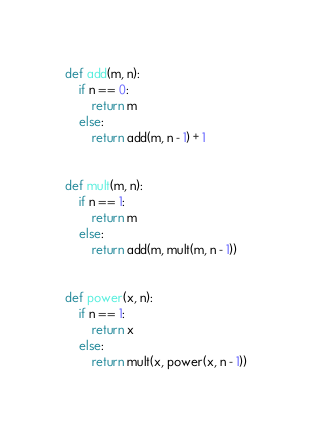Convert code to text. <code><loc_0><loc_0><loc_500><loc_500><_Python_>def add(m, n):
    if n == 0:
        return m
    else:
        return add(m, n - 1) + 1


def mult(m, n):
    if n == 1:
        return m
    else:
        return add(m, mult(m, n - 1))


def power(x, n):
    if n == 1:
        return x
    else:
        return mult(x, power(x, n - 1))
</code> 